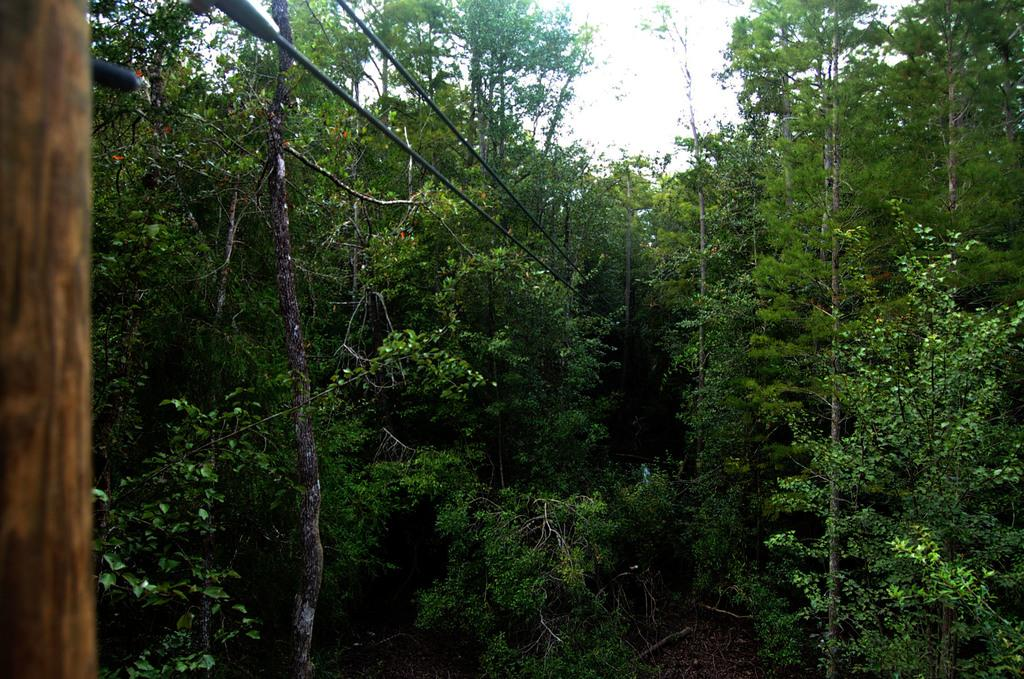What objects can be seen on the left side of the image? There are ropes on the left side of the image. What is located in the middle of the image? There are trees in the middle of the image. What is visible at the top of the image? The sky is visible at the top of the image. What type of songs can be heard coming from the log in the image? There are no songs or sounds present in the image, as it is a still image featuring a log and trees. Can you see a duck in the image? There is no duck present in the image; it features ropes, a log, trees, and the sky. 